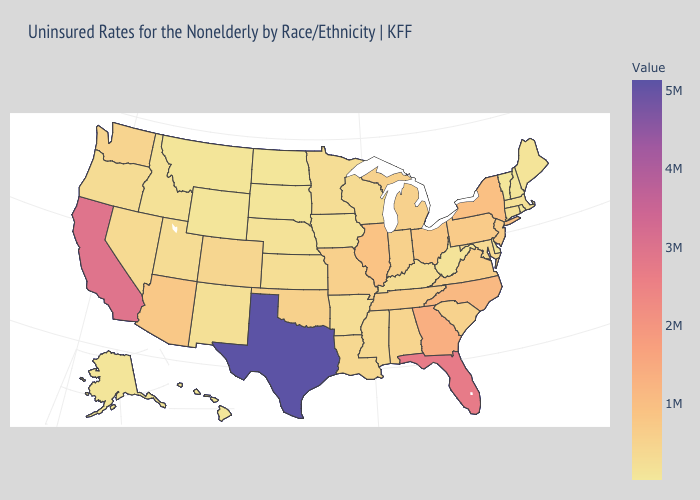Among the states that border Minnesota , does Wisconsin have the highest value?
Give a very brief answer. Yes. Among the states that border Virginia , which have the lowest value?
Quick response, please. West Virginia. Is the legend a continuous bar?
Concise answer only. Yes. Does the map have missing data?
Concise answer only. No. Which states hav the highest value in the South?
Answer briefly. Texas. 